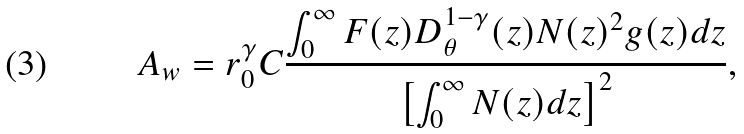Convert formula to latex. <formula><loc_0><loc_0><loc_500><loc_500>A _ { w } = r _ { 0 } ^ { \gamma } C \frac { \int _ { 0 } ^ { \infty } F ( z ) D _ { \theta } ^ { 1 - \gamma } ( z ) N ( z ) ^ { 2 } g ( z ) d z } { \left [ \int _ { 0 } ^ { \infty } N ( z ) d z \right ] ^ { 2 } } ,</formula> 